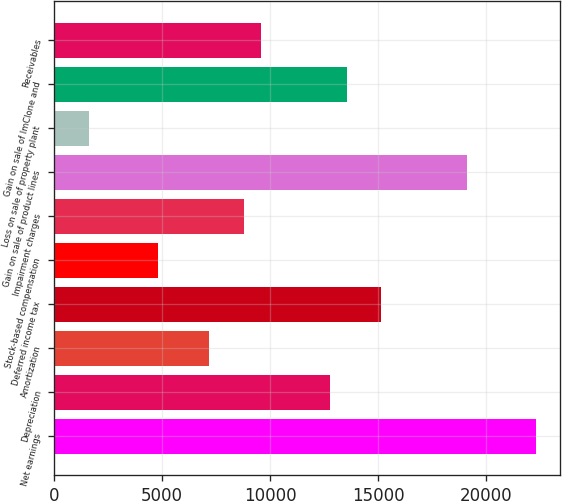Convert chart. <chart><loc_0><loc_0><loc_500><loc_500><bar_chart><fcel>Net earnings<fcel>Depreciation<fcel>Amortization<fcel>Deferred income tax<fcel>Stock-based compensation<fcel>Impairment charges<fcel>Gain on sale of product lines<fcel>Loss on sale of property plant<fcel>Gain on sale of ImClone and<fcel>Receivables<nl><fcel>22323.8<fcel>12758.6<fcel>7178.9<fcel>15149.9<fcel>4787.6<fcel>8773.1<fcel>19135.4<fcel>1599.2<fcel>13555.7<fcel>9570.2<nl></chart> 